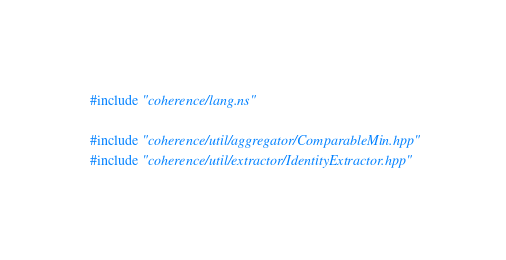Convert code to text. <code><loc_0><loc_0><loc_500><loc_500><_C++_>#include "coherence/lang.ns"

#include "coherence/util/aggregator/ComparableMin.hpp"
#include "coherence/util/extractor/IdentityExtractor.hpp"</code> 